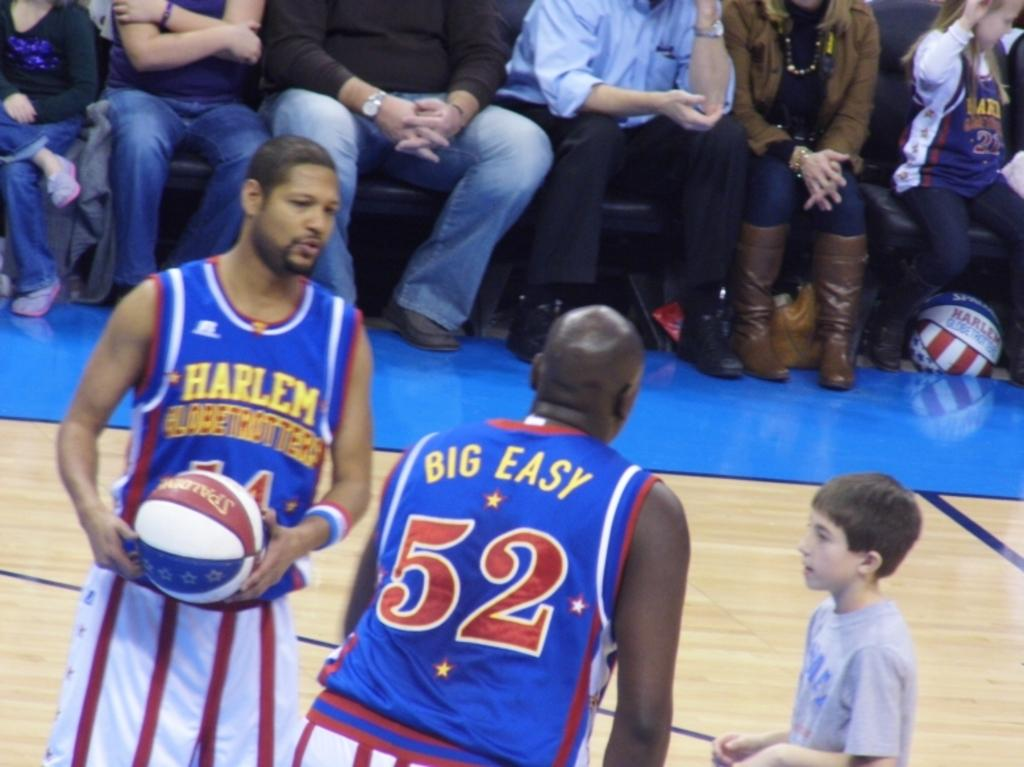<image>
Present a compact description of the photo's key features. Basketball game with blue uniforms and Harlem Globetrotters on the front in yellow. 